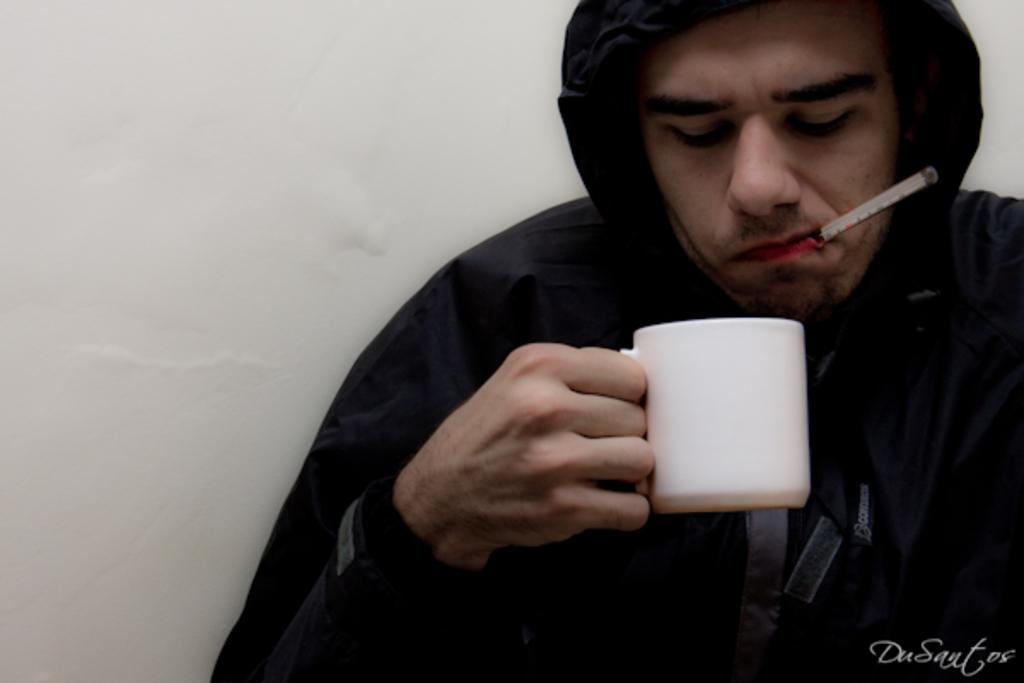Who is present in the image? There is a man in the image. What is the man wearing? The man is wearing a black jacket. What is the man holding in the image? The man is holding a cup. Can you identify any other objects in the image? Yes, there is a thermometer in the image. What shape is the man's eye in the image? There is no information about the shape of the man's eye in the image, as the focus is on his clothing and what he is holding. 